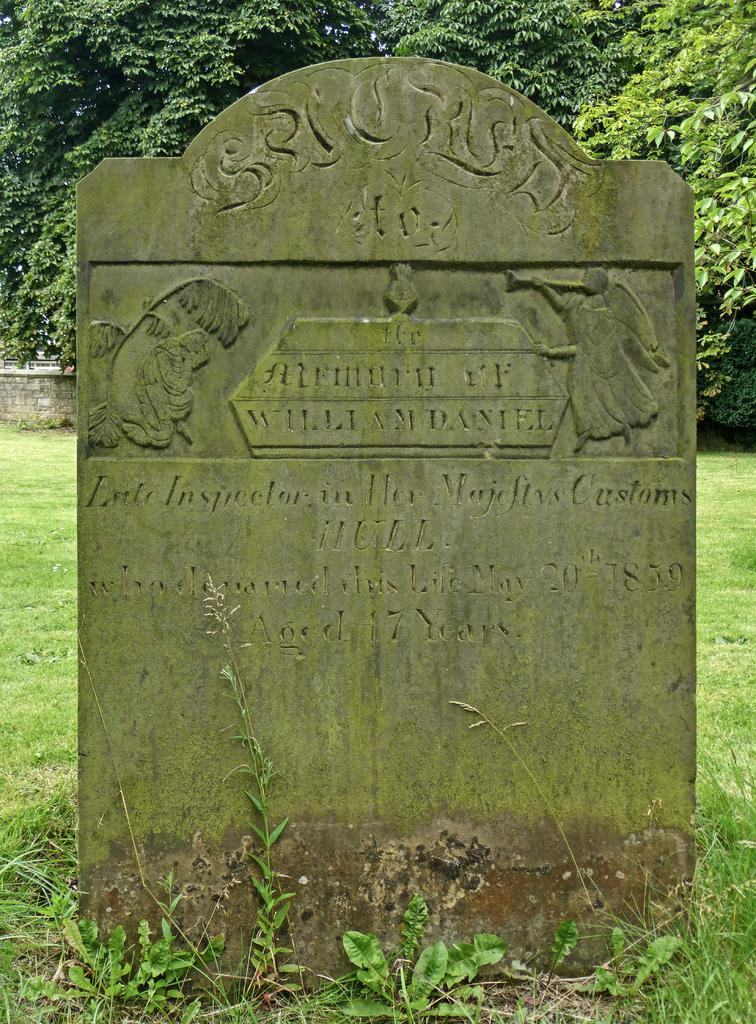What is the main object in the image? There is a headstone in the image. What can be found on the headstone? There is text and sculptures on the headstone. What is visible in the background of the image? There are trees in the background of the image. How many cows can be seen grazing near the headstone in the image? There are no cows present in the image. Is there a cobweb visible on the sculptures of the headstone in the image? There is no mention of a cobweb in the image, and it cannot be determined from the provided facts. 